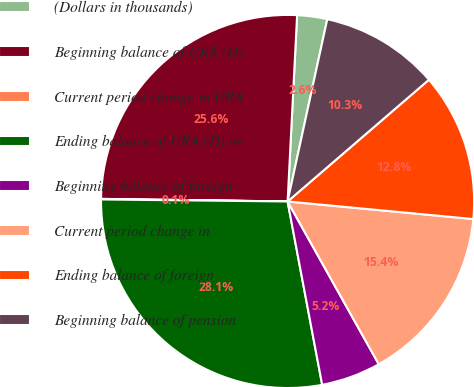Convert chart to OTSL. <chart><loc_0><loc_0><loc_500><loc_500><pie_chart><fcel>(Dollars in thousands)<fcel>Beginning balance of URA (D)<fcel>Current period change in URA<fcel>Ending balance of URA (D) on<fcel>Beginning balance of foreign<fcel>Current period change in<fcel>Ending balance of foreign<fcel>Beginning balance of pension<nl><fcel>2.6%<fcel>25.59%<fcel>0.05%<fcel>28.14%<fcel>5.16%<fcel>15.37%<fcel>12.82%<fcel>10.27%<nl></chart> 